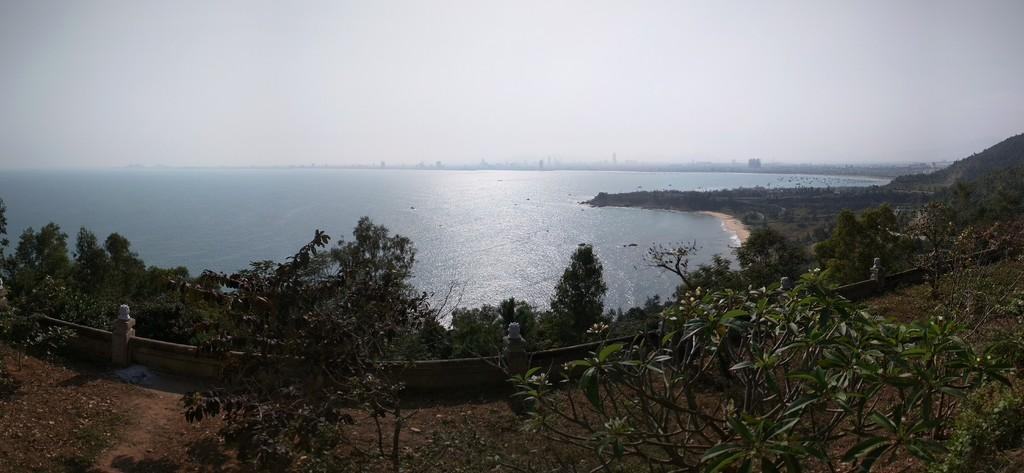What is the main element present in the image? There is water in the image. What else can be seen in the image besides water? There are plants and a hill in the image. What is visible at the top of the image? The sky is visible at the top of the image. How many sheep are present at the party in the image? There are no sheep or party present in the image; it features water, plants, a hill, and the sky. 